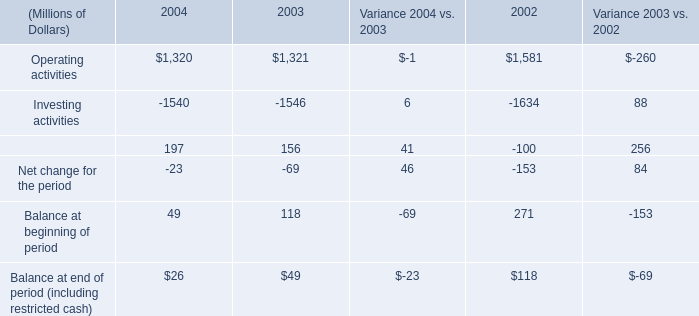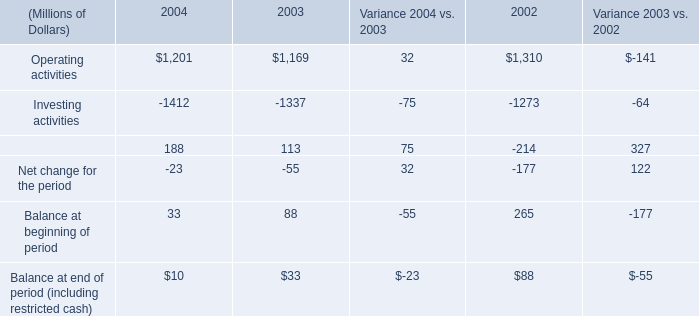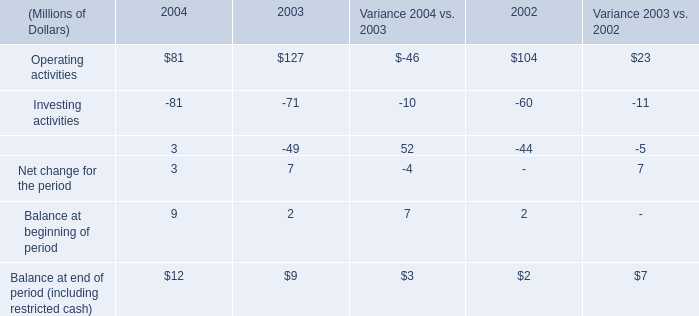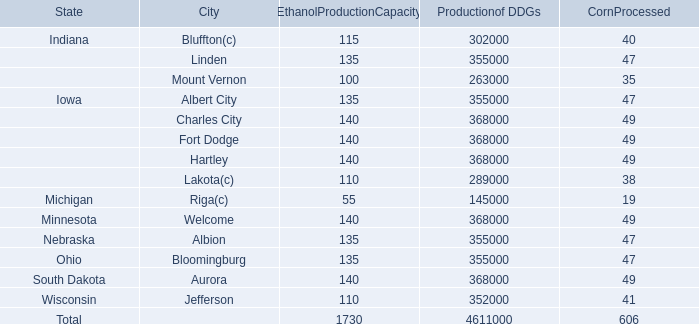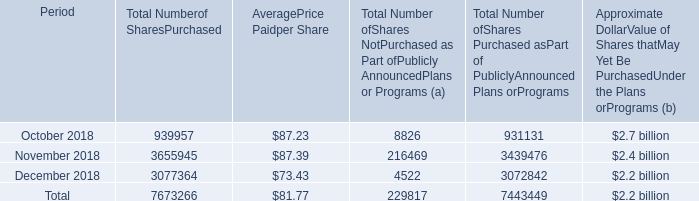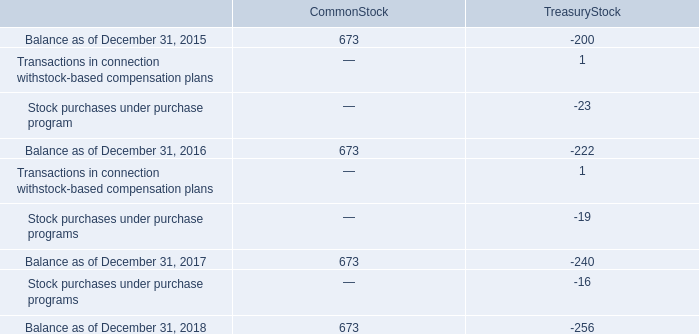if the same amount was spent monthly for 24 months purchasing $ 2.5 billion of common stock , what was the monthly average spent be , in billions? 
Computations: (2.5 / 24)
Answer: 0.10417. What's the sum of Operating activities of 2004, and Indiana of Productionof DDGs ? 
Computations: (1320.0 + 302000.0)
Answer: 303320.0. 